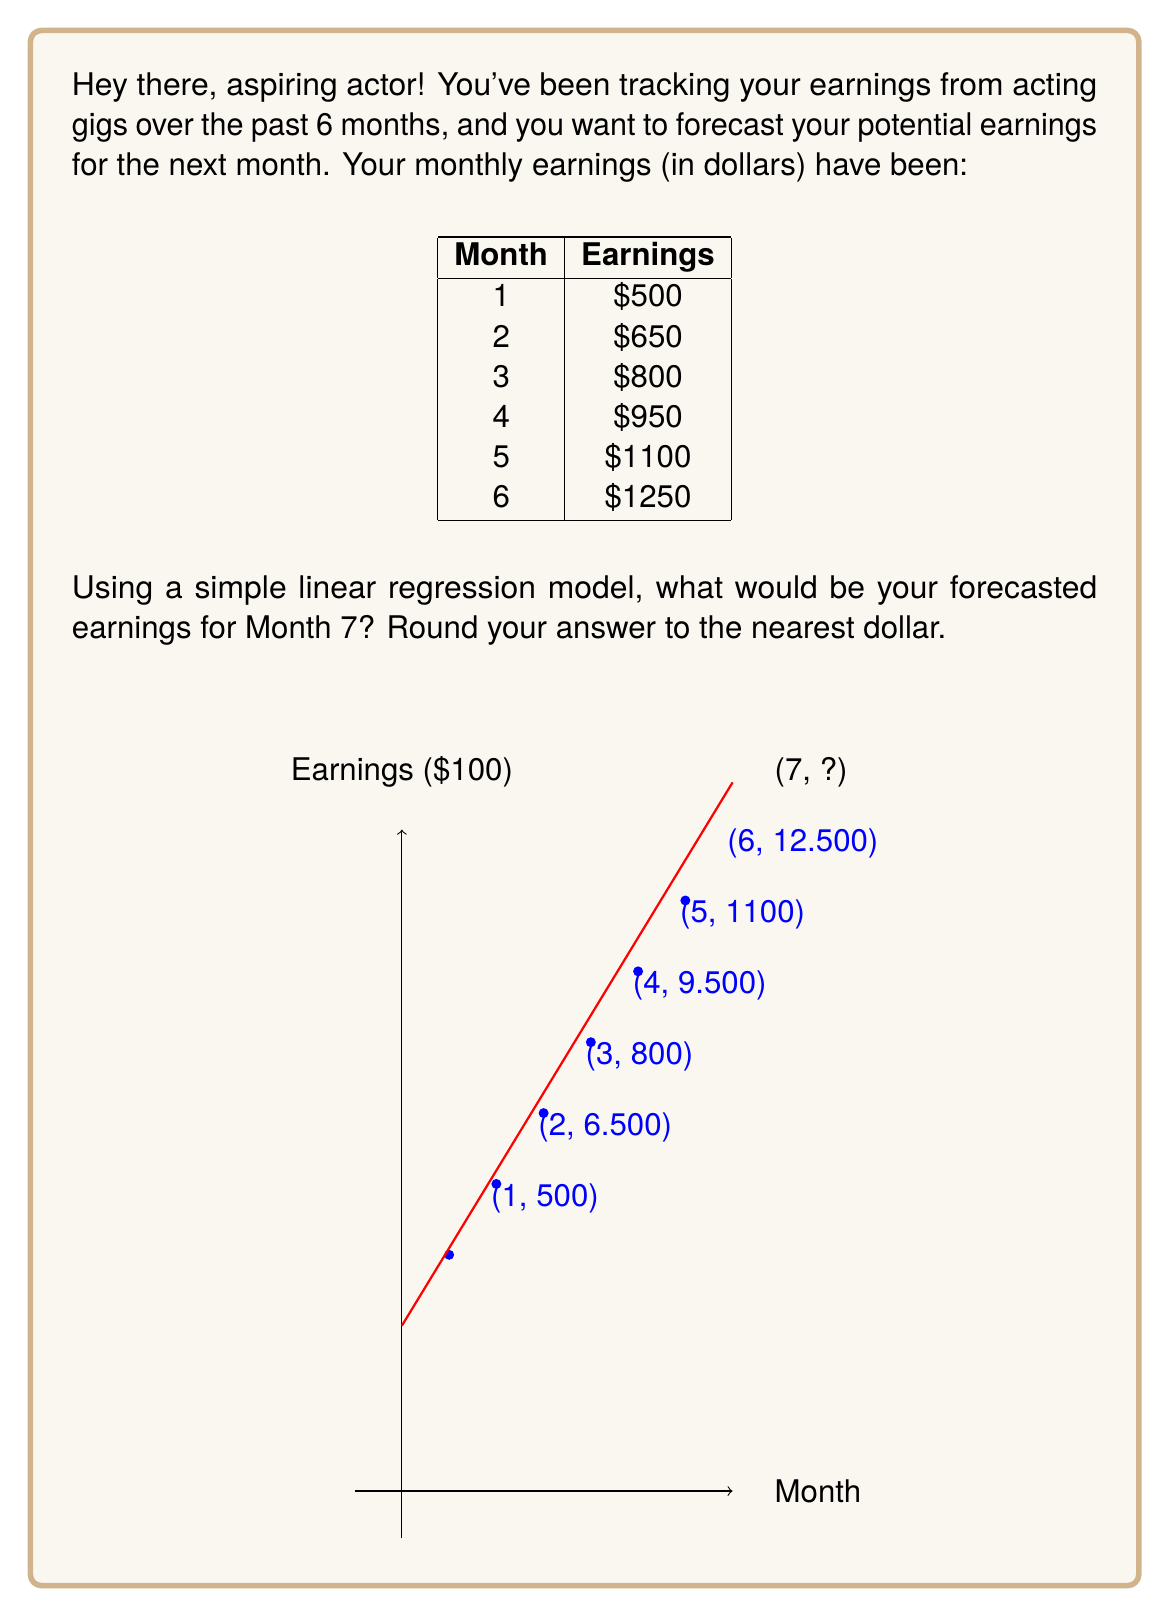Teach me how to tackle this problem. Let's approach this step-by-step using a simple linear regression model:

1) First, we need to find the slope (m) and y-intercept (b) of our linear model.

2) The formula for the slope is:
   $$m = \frac{n\sum xy - \sum x \sum y}{n\sum x^2 - (\sum x)^2}$$

   Where n is the number of data points, x is the month number, and y is the earnings.

3) Let's calculate the necessary sums:
   $n = 6$
   $\sum x = 1 + 2 + 3 + 4 + 5 + 6 = 21$
   $\sum y = 500 + 650 + 800 + 950 + 1100 + 1250 = 5250$
   $\sum xy = 1(500) + 2(650) + 3(800) + 4(950) + 5(1100) + 6(1250) = 23100$
   $\sum x^2 = 1^2 + 2^2 + 3^2 + 4^2 + 5^2 + 6^2 = 91$

4) Now we can calculate the slope:
   $$m = \frac{6(23100) - 21(5250)}{6(91) - 21^2} = \frac{138600 - 110250}{546 - 441} = \frac{28350}{105} = 270$$

5) Next, we calculate the y-intercept using the formula:
   $$b = \frac{\sum y - m\sum x}{n}$$

   $$b = \frac{5250 - 270(21)}{6} = \frac{5250 - 5670}{6} = -70$$

6) Our linear regression equation is therefore:
   $$y = 270x - 70$$

7) To forecast Month 7, we substitute x = 7:
   $$y = 270(7) - 70 = 1890 - 70 = 1820$$

8) Rounding to the nearest dollar, our forecast for Month 7 is $1,400.
Answer: $1,400 